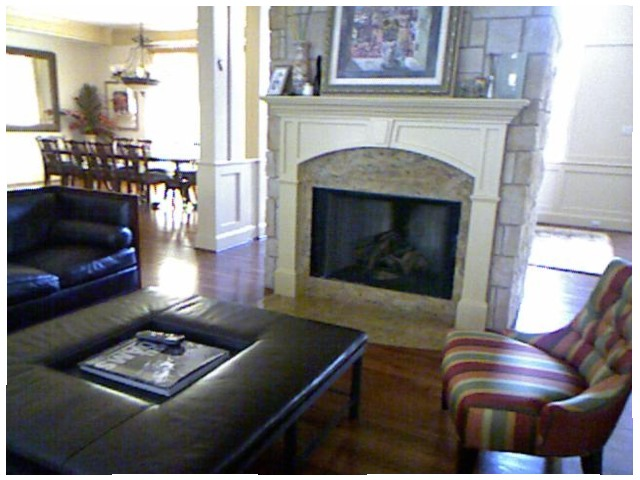<image>
Can you confirm if the remote control is on the sofa? No. The remote control is not positioned on the sofa. They may be near each other, but the remote control is not supported by or resting on top of the sofa. Is there a lamp on the dining table? No. The lamp is not positioned on the dining table. They may be near each other, but the lamp is not supported by or resting on top of the dining table. Is there a painting behind the book? Yes. From this viewpoint, the painting is positioned behind the book, with the book partially or fully occluding the painting. Is there a picture above the mantel? Yes. The picture is positioned above the mantel in the vertical space, higher up in the scene. Is there a chair to the right of the fireplace? Yes. From this viewpoint, the chair is positioned to the right side relative to the fireplace. 